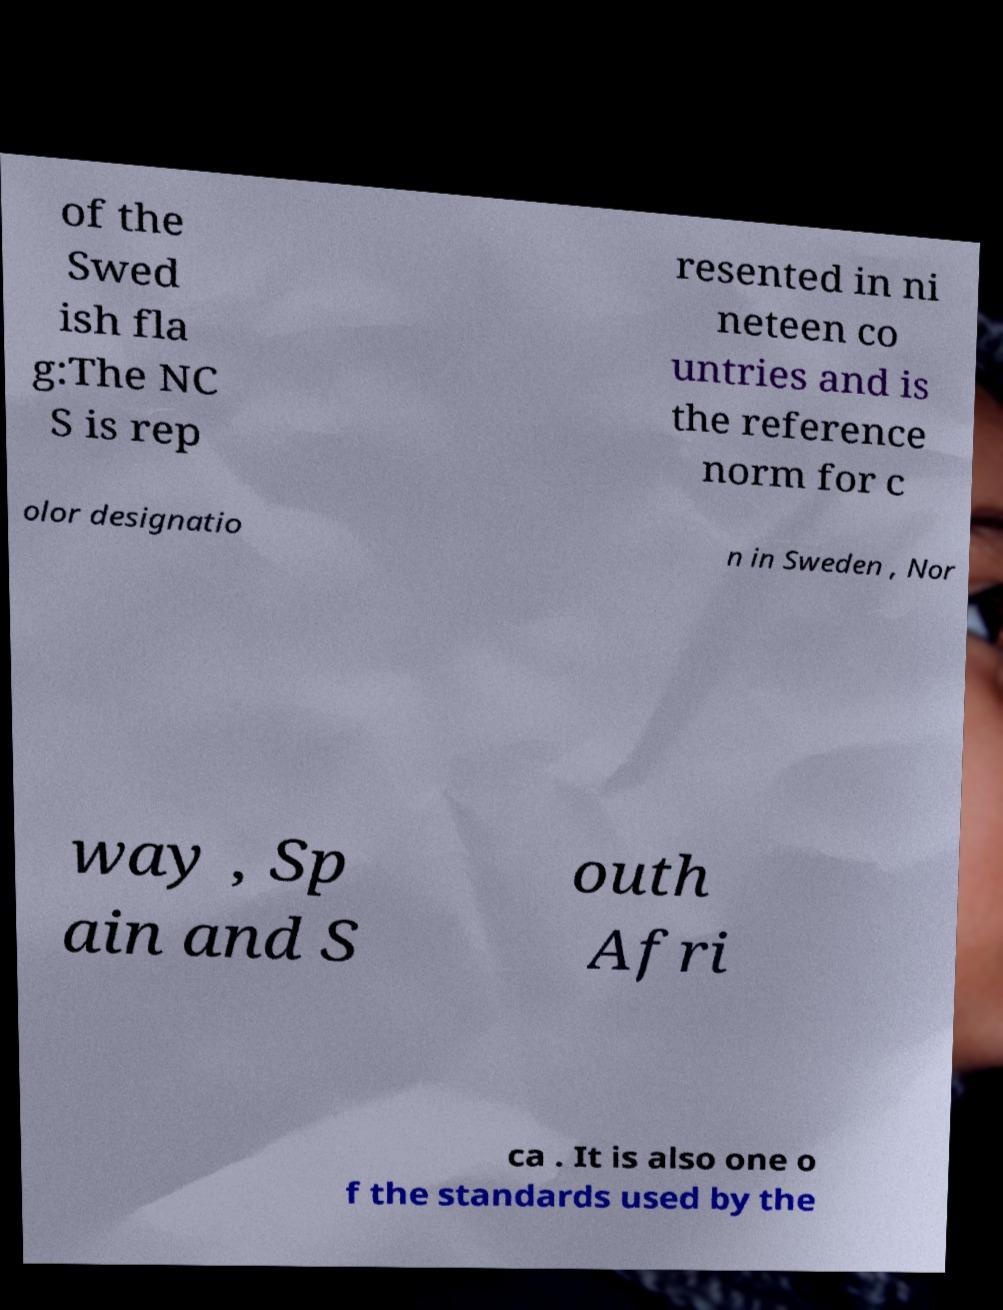I need the written content from this picture converted into text. Can you do that? of the Swed ish fla g:The NC S is rep resented in ni neteen co untries and is the reference norm for c olor designatio n in Sweden , Nor way , Sp ain and S outh Afri ca . It is also one o f the standards used by the 